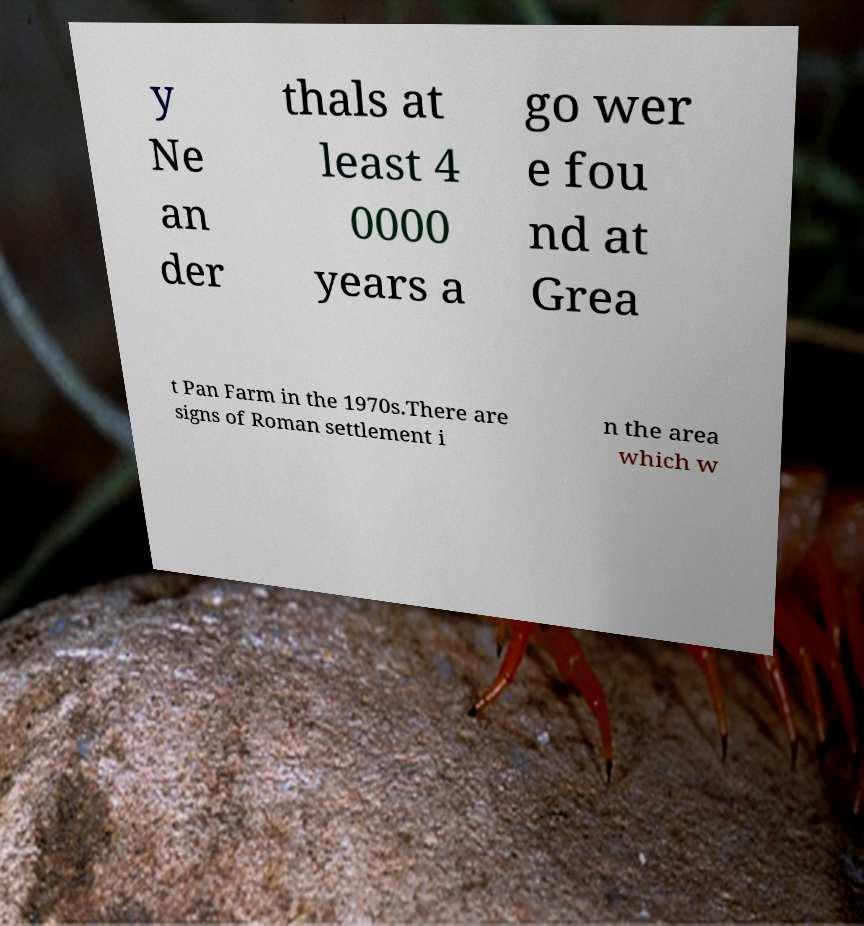Could you assist in decoding the text presented in this image and type it out clearly? y Ne an der thals at least 4 0000 years a go wer e fou nd at Grea t Pan Farm in the 1970s.There are signs of Roman settlement i n the area which w 